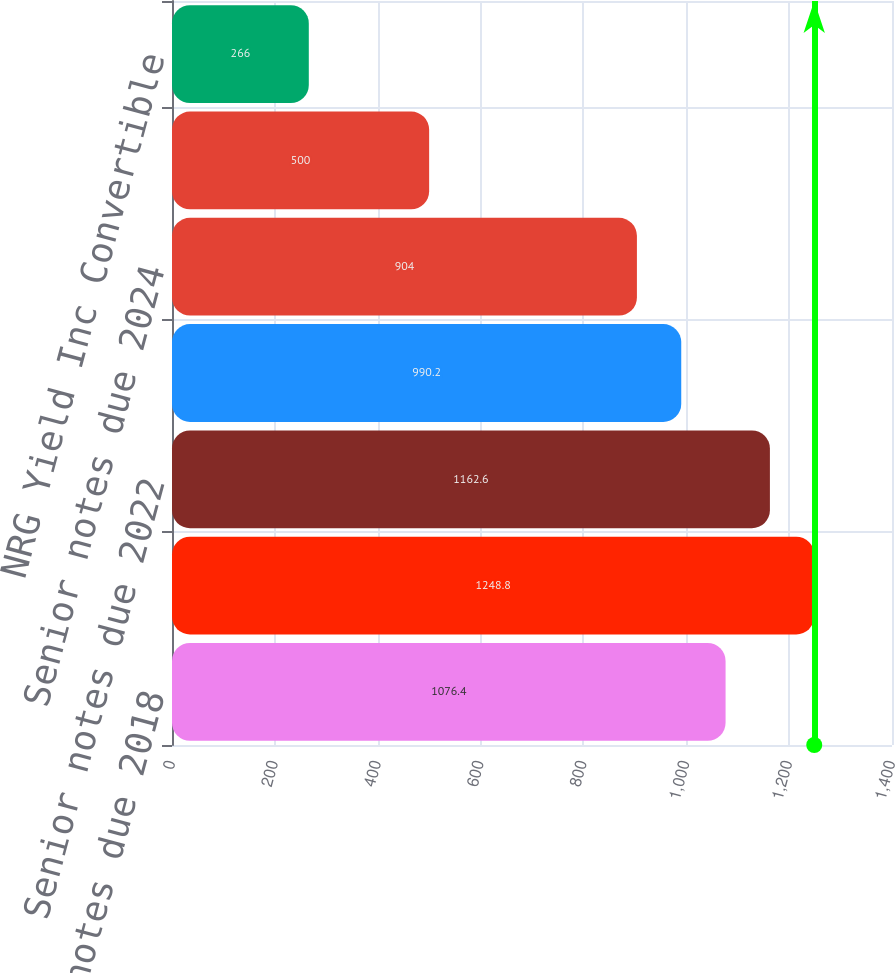<chart> <loc_0><loc_0><loc_500><loc_500><bar_chart><fcel>Senior notes due 2018<fcel>Senior notes due 2021<fcel>Senior notes due 2022<fcel>Senior notes due 2023<fcel>Senior notes due 2024<fcel>NRG Yield Operating LLC Senior<fcel>NRG Yield Inc Convertible<nl><fcel>1076.4<fcel>1248.8<fcel>1162.6<fcel>990.2<fcel>904<fcel>500<fcel>266<nl></chart> 